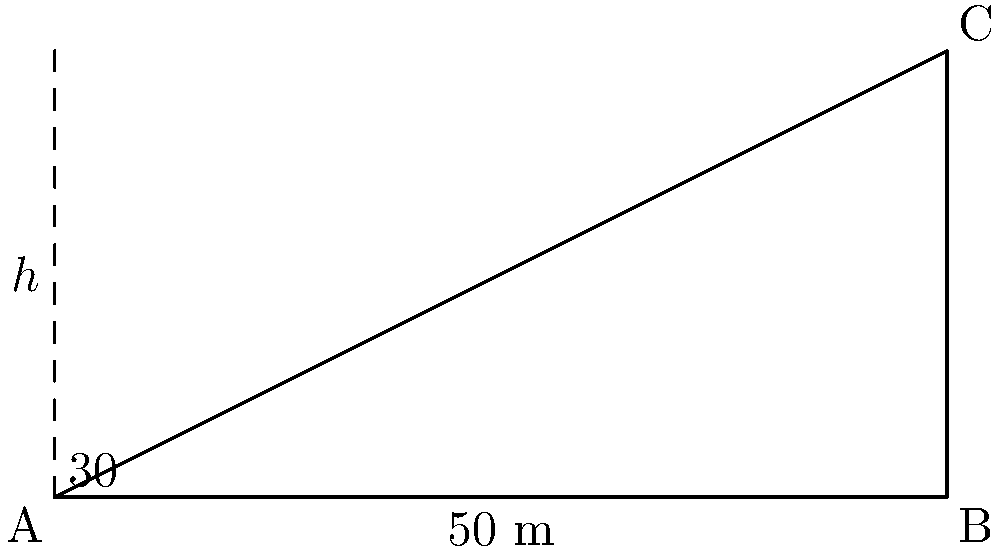An engineer needs to determine the height of a building using trigonometric ratios. Standing 50 meters away from the base of the building, they measure the angle of elevation to the top of the building to be 30°. Using this information, calculate the height of the building to the nearest meter. To solve this problem, we'll use the tangent ratio in a right-angled triangle. Let's approach this step-by-step:

1) In the right-angled triangle formed, we know:
   - The adjacent side (distance from the engineer to the building) = 50 m
   - The angle of elevation = 30°
   - We need to find the opposite side (height of the building)

2) The tangent ratio is defined as:
   $\tan \theta = \frac{\text{opposite}}{\text{adjacent}}$

3) Substituting our known values:
   $\tan 30° = \frac{h}{50}$

4) We can rearrange this to solve for $h$:
   $h = 50 \tan 30°$

5) Now, let's calculate:
   $\tan 30° \approx 0.5773502692$
   
   $h = 50 \times 0.5773502692 \approx 28.86751346$ meters

6) Rounding to the nearest meter:
   $h \approx 29$ meters

Therefore, the height of the building is approximately 29 meters.
Answer: 29 meters 